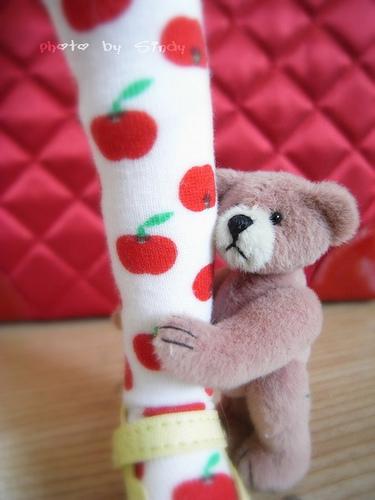What color are the socks?
Concise answer only. White. Where is a tufted piece of red cloth?
Give a very brief answer. Background. How many of the teddy bears eyes are shown in the photo?
Give a very brief answer. 1. 